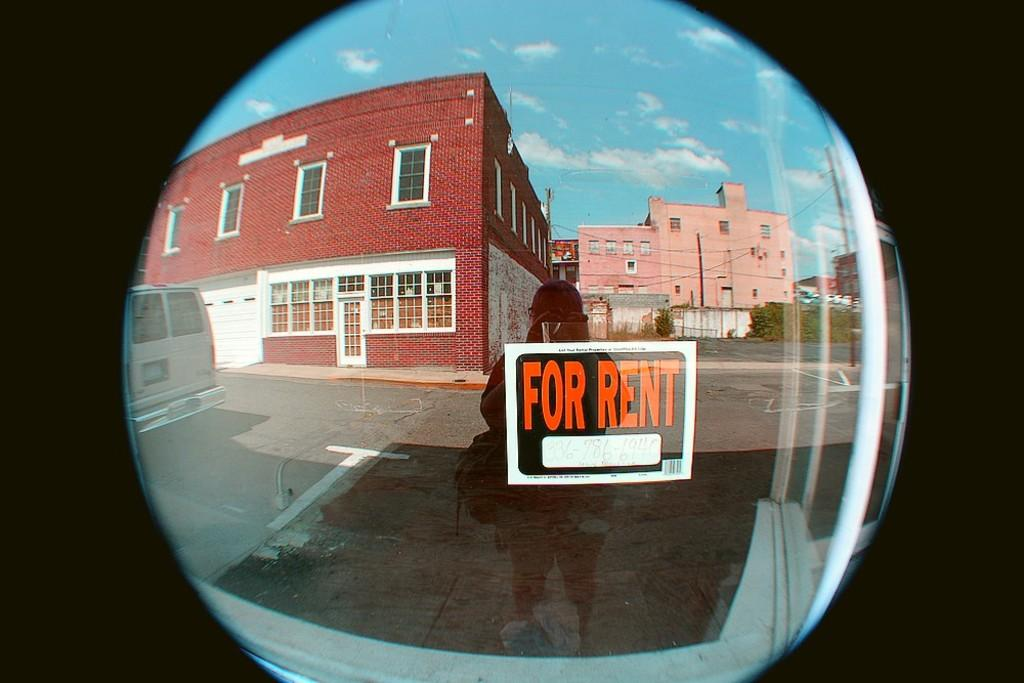<image>
Write a terse but informative summary of the picture. A fishbowl view of someone on a street holding a FOR RENT sign with a phone number 336-786-6940 on it. 